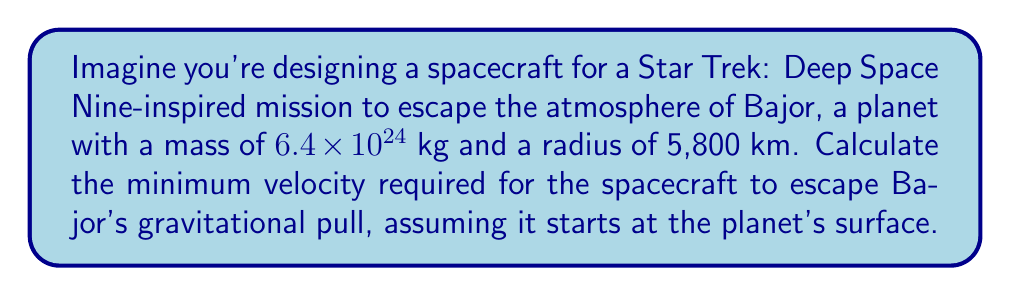Can you answer this question? To solve this problem, we'll use the escape velocity formula:

$$v_e = \sqrt{\frac{2GM}{R}}$$

Where:
$v_e$ = escape velocity
$G$ = gravitational constant $(6.67 \times 10^{-11} \text{ N}\cdot\text{m}^2/\text{kg}^2)$
$M$ = mass of the planet
$R$ = radius of the planet

Step 1: Convert the radius to meters
$R = 5,800 \text{ km} = 5.8 \times 10^6 \text{ m}$

Step 2: Substitute the values into the equation
$$v_e = \sqrt{\frac{2 \cdot (6.67 \times 10^{-11}) \cdot (6.4 \times 10^{24})}{5.8 \times 10^6}}$$

Step 3: Calculate the result
$$v_e = \sqrt{14,776,275,862} \approx 11,156 \text{ m/s}$$

Step 4: Convert to km/s
$v_e \approx 11.16 \text{ km/s}$
Answer: 11.16 km/s 